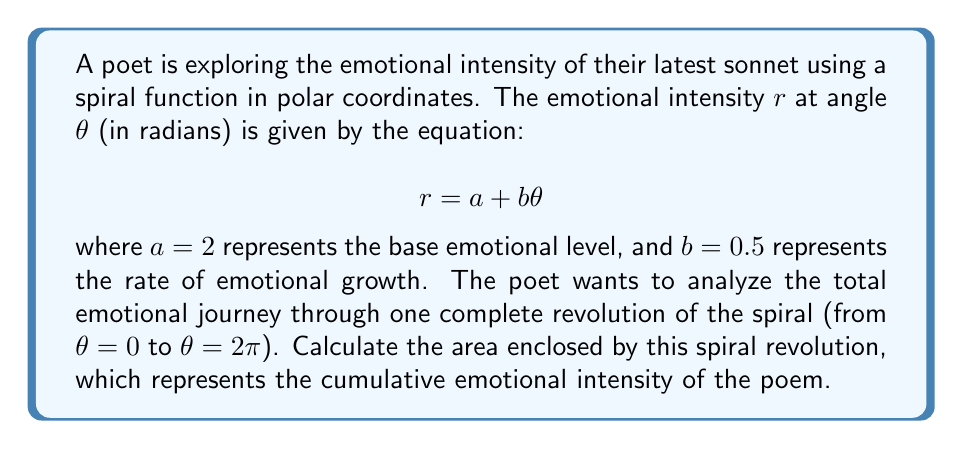What is the answer to this math problem? To solve this problem, we'll follow these steps:

1) The area enclosed by a polar curve over an interval $[\alpha, \beta]$ is given by the formula:

   $$A = \frac{1}{2} \int_{\alpha}^{\beta} r^2 d\theta$$

2) In our case, $r = a + b\theta$ where $a = 2$ and $b = 0.5$. We need to integrate from $\alpha = 0$ to $\beta = 2\pi$.

3) Let's square the function $r$:

   $$r^2 = (a + b\theta)^2 = a^2 + 2ab\theta + b^2\theta^2$$

4) Now, let's set up the integral:

   $$A = \frac{1}{2} \int_{0}^{2\pi} (a^2 + 2ab\theta + b^2\theta^2) d\theta$$

5) Integrate each term:

   $$A = \frac{1}{2} [a^2\theta + ab\theta^2 + \frac{1}{3}b^2\theta^3]_{0}^{2\pi}$$

6) Substitute the limits:

   $$A = \frac{1}{2} [(a^2(2\pi) + ab(2\pi)^2 + \frac{1}{3}b^2(2\pi)^3) - (0)]$$

7) Now, let's substitute the values $a = 2$ and $b = 0.5$:

   $$A = \frac{1}{2} [(2^2(2\pi) + 2(0.5)(2\pi)^2 + \frac{1}{3}(0.5)^2(2\pi)^3)]$$

8) Simplify:

   $$A = \frac{1}{2} [8\pi + 2\pi^2 + \frac{1}{3}\pi^3]$$

   $$A = 4\pi + \pi^2 + \frac{1}{6}\pi^3$$

This represents the total emotional intensity experienced through one revolution of the poem.
Answer: $4\pi + \pi^2 + \frac{1}{6}\pi^3$ square units 